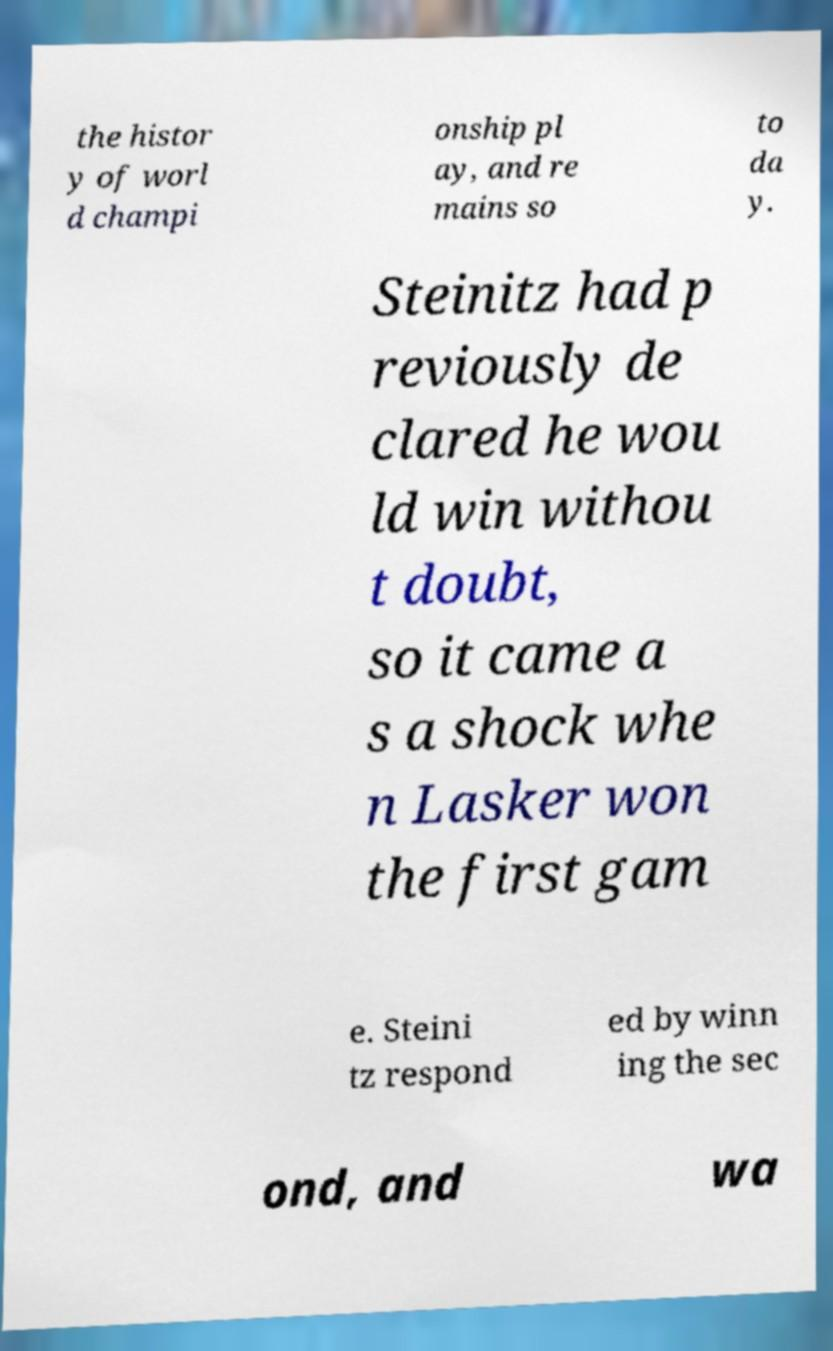There's text embedded in this image that I need extracted. Can you transcribe it verbatim? the histor y of worl d champi onship pl ay, and re mains so to da y. Steinitz had p reviously de clared he wou ld win withou t doubt, so it came a s a shock whe n Lasker won the first gam e. Steini tz respond ed by winn ing the sec ond, and wa 